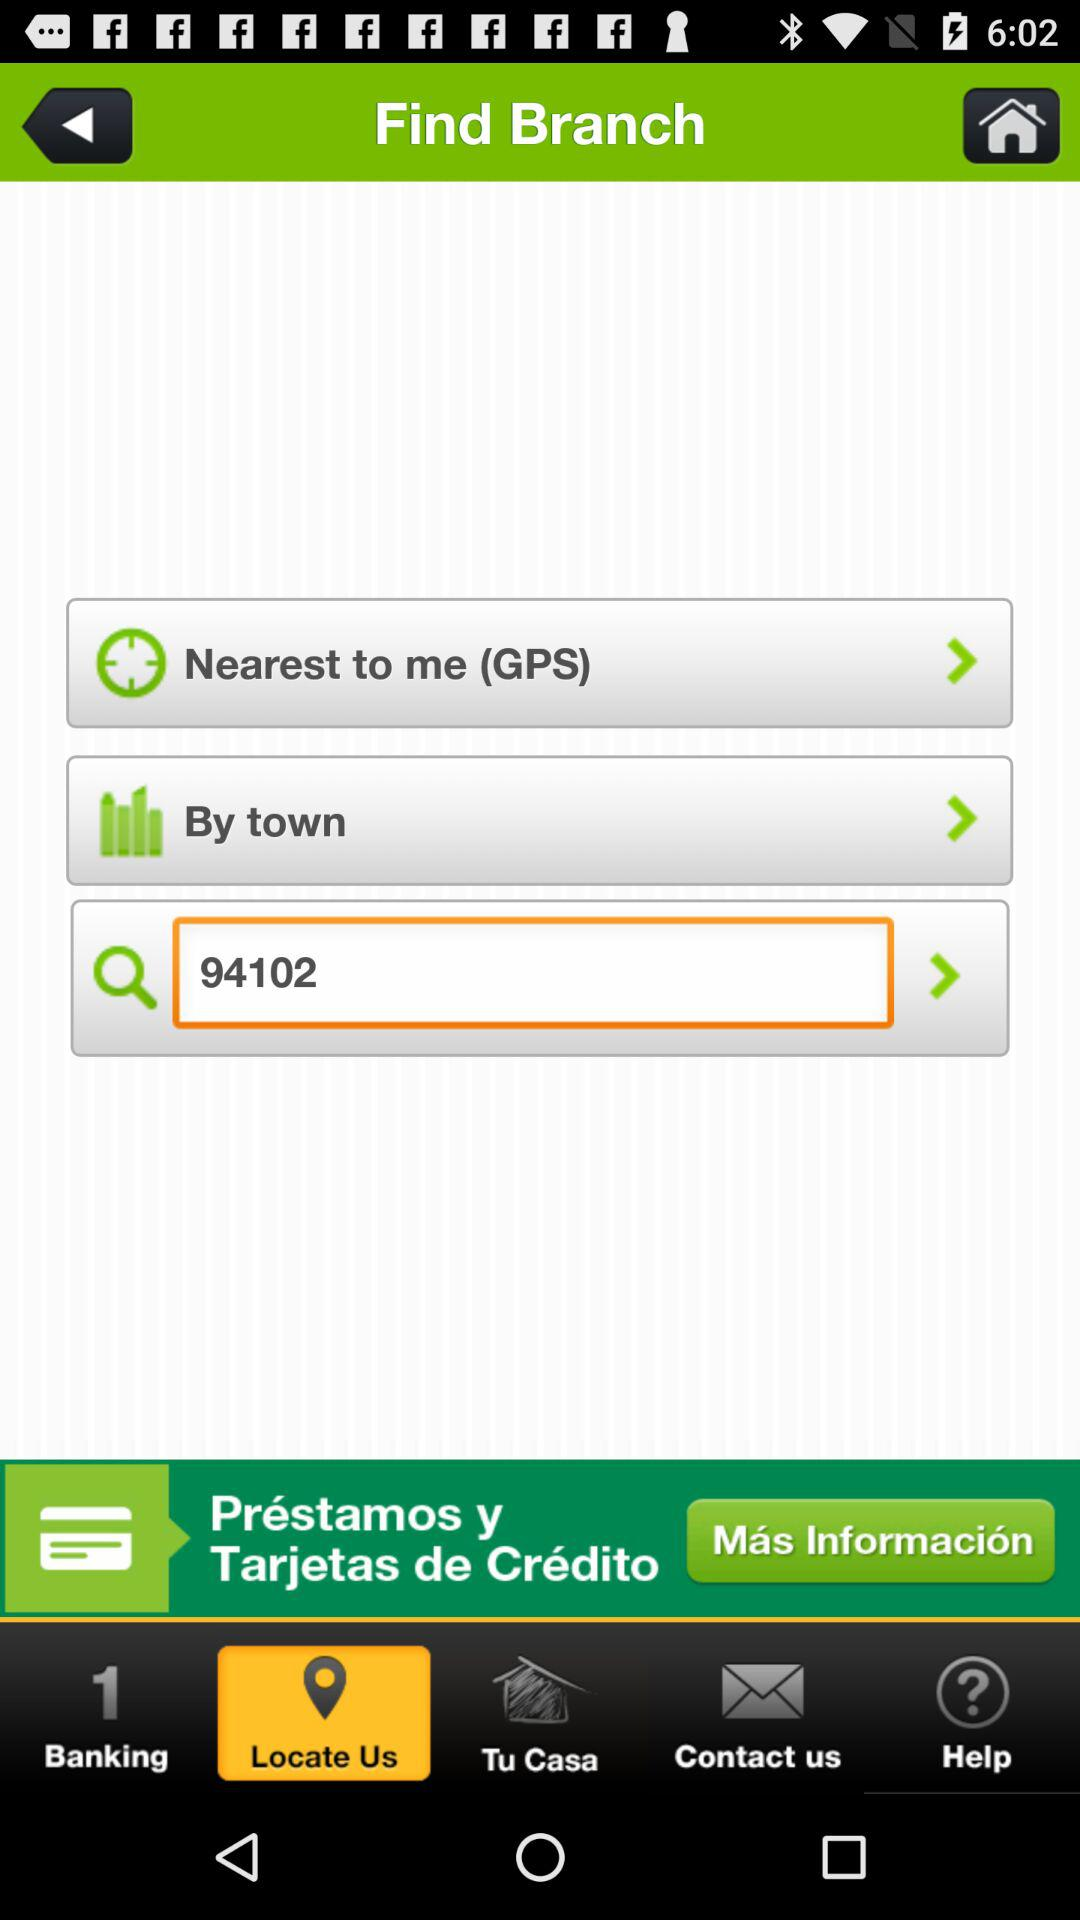Which tab has selected? The tab is "Locate Us". 